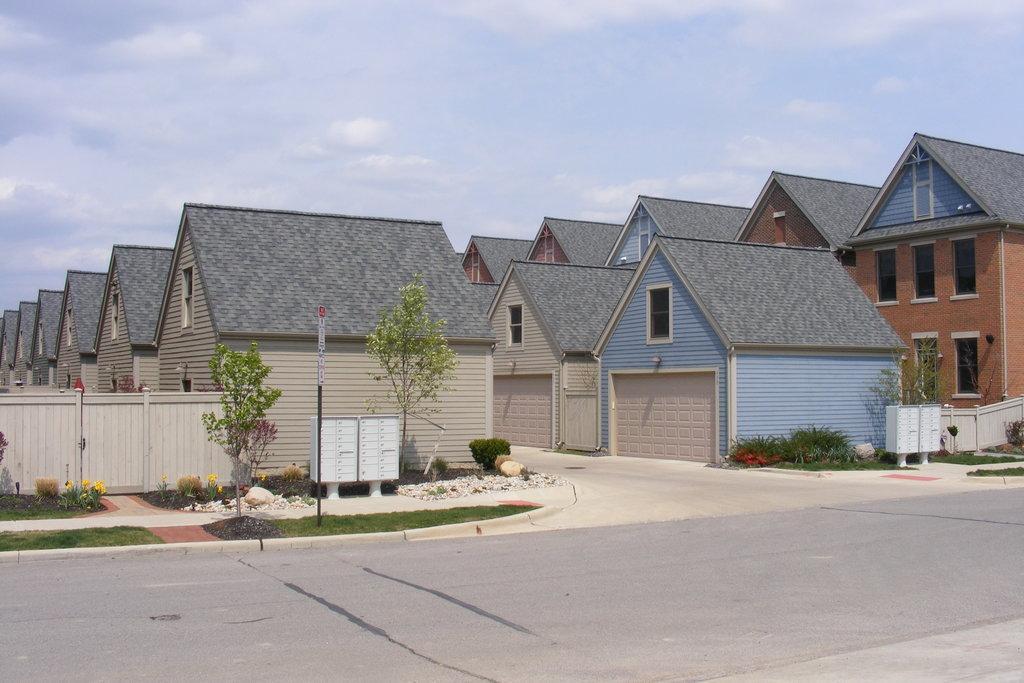In one or two sentences, can you explain what this image depicts? In front of the image there is road, beside the a road there is grass and sign boards on the pavement, beside that there are trees, wooden fence, flowers on plants, electrical boxes and there are houses, at the top of the image there are clouds in the sky. 